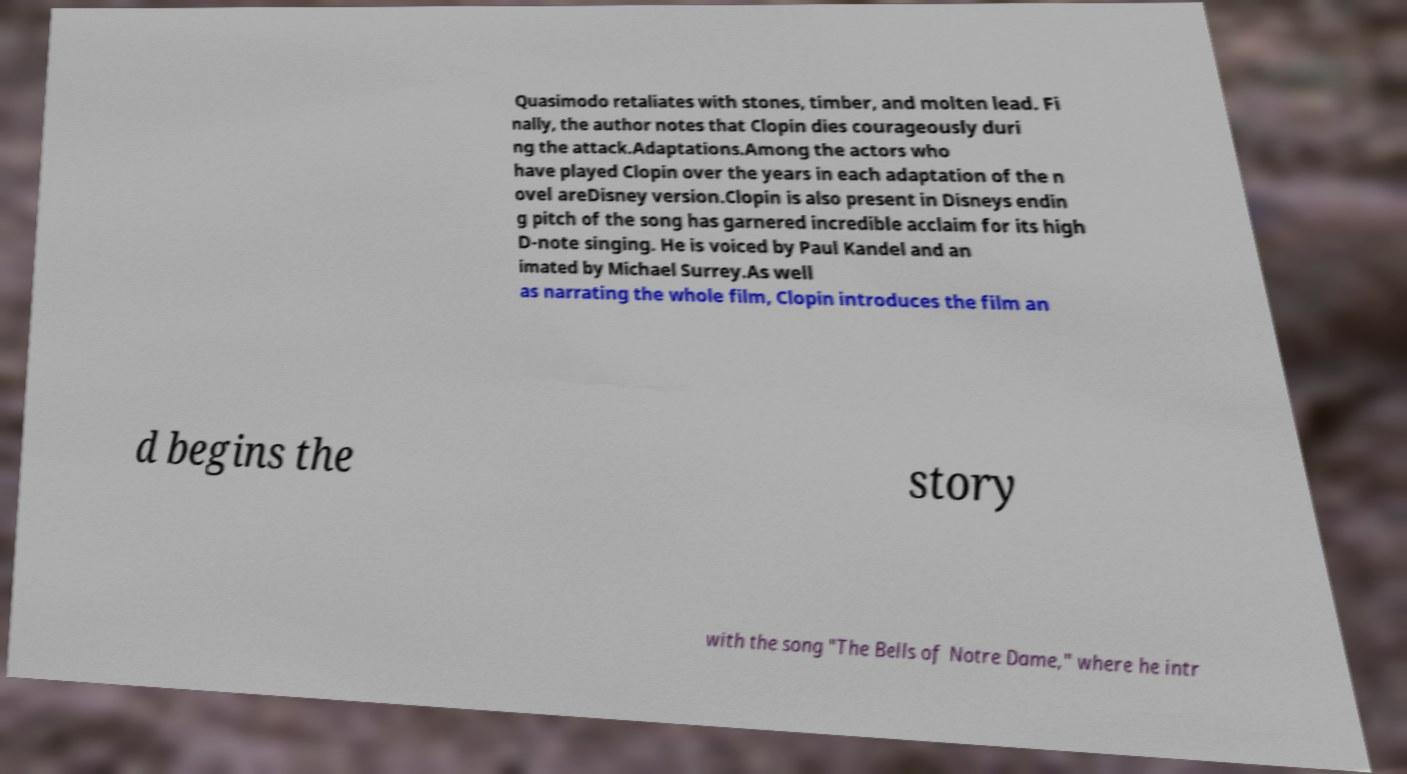Could you extract and type out the text from this image? Quasimodo retaliates with stones, timber, and molten lead. Fi nally, the author notes that Clopin dies courageously duri ng the attack.Adaptations.Among the actors who have played Clopin over the years in each adaptation of the n ovel areDisney version.Clopin is also present in Disneys endin g pitch of the song has garnered incredible acclaim for its high D-note singing. He is voiced by Paul Kandel and an imated by Michael Surrey.As well as narrating the whole film, Clopin introduces the film an d begins the story with the song "The Bells of Notre Dame," where he intr 